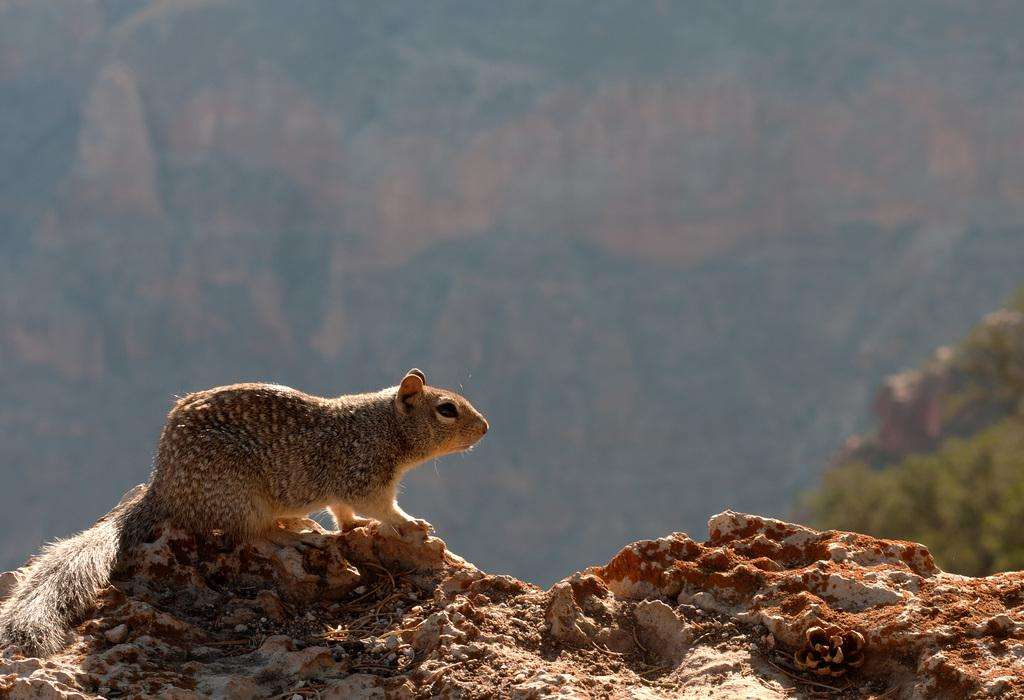What animal can be seen in the image? There is a squirrel in the image. What is the squirrel standing on? The squirrel is standing on a rock surface. Can you describe the background of the image? The background of the image is slightly blurry. What type of leather is the squirrel using to protect itself from the attack in the image? There is no attack or leather present in the image; it simply features a squirrel standing on a rock surface with a slightly blurry background. 